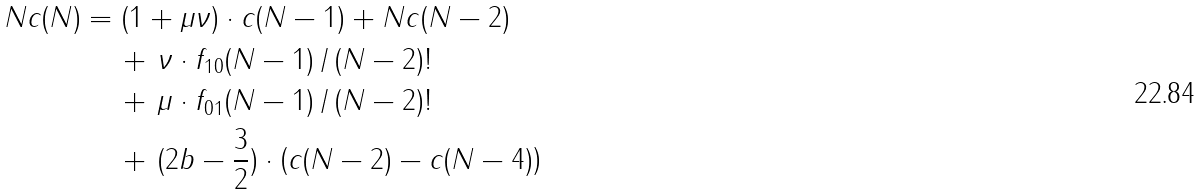<formula> <loc_0><loc_0><loc_500><loc_500>N c ( N ) & = ( 1 + \mu \nu ) \cdot c ( N - 1 ) + N c ( N - 2 ) \\ & \quad \, + \, \nu \cdot f _ { 1 0 } ( N - 1 ) \, / \, ( N - 2 ) ! \\ & \quad \, + \, \mu \cdot f _ { 0 1 } ( N - 1 ) \, / \, ( N - 2 ) ! \\ & \quad \, + \, ( 2 b - \frac { 3 } { 2 } ) \cdot \left ( c ( N - 2 ) - c ( N - 4 ) \right )</formula> 